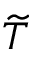Convert formula to latex. <formula><loc_0><loc_0><loc_500><loc_500>\widetilde { T }</formula> 